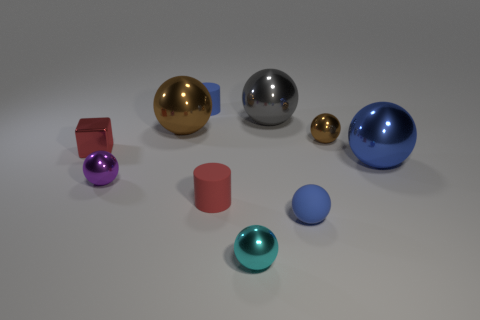Subtract all brown balls. How many balls are left? 5 Subtract all blue shiny balls. How many balls are left? 6 Subtract all green balls. Subtract all brown cylinders. How many balls are left? 7 Subtract all cylinders. How many objects are left? 8 Subtract 1 red cylinders. How many objects are left? 9 Subtract all brown metallic objects. Subtract all tiny rubber things. How many objects are left? 5 Add 6 big brown balls. How many big brown balls are left? 7 Add 1 tiny brown metal spheres. How many tiny brown metal spheres exist? 2 